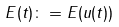Convert formula to latex. <formula><loc_0><loc_0><loc_500><loc_500>E ( t ) \colon = E ( u ( t ) )</formula> 